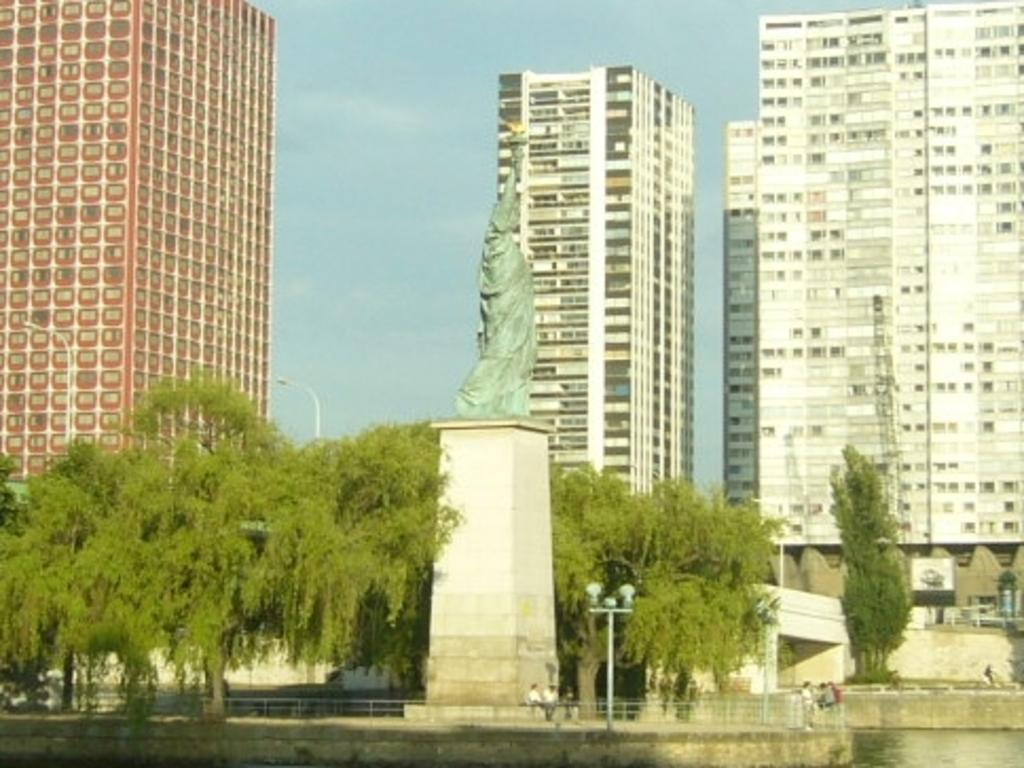What is located in the center of the image? There are trees and a statue in the center of the image. What can be seen in the background of the image? There are buildings in the background of the image. What objects are present in the image that are used for support or guidance? There are poles in the image. What are the people in the center of the image doing? There are persons standing and sitting in the center of the image. How many fish are swimming in the statue in the image? There are no fish present in the image, and the statue does not depict any fish. 